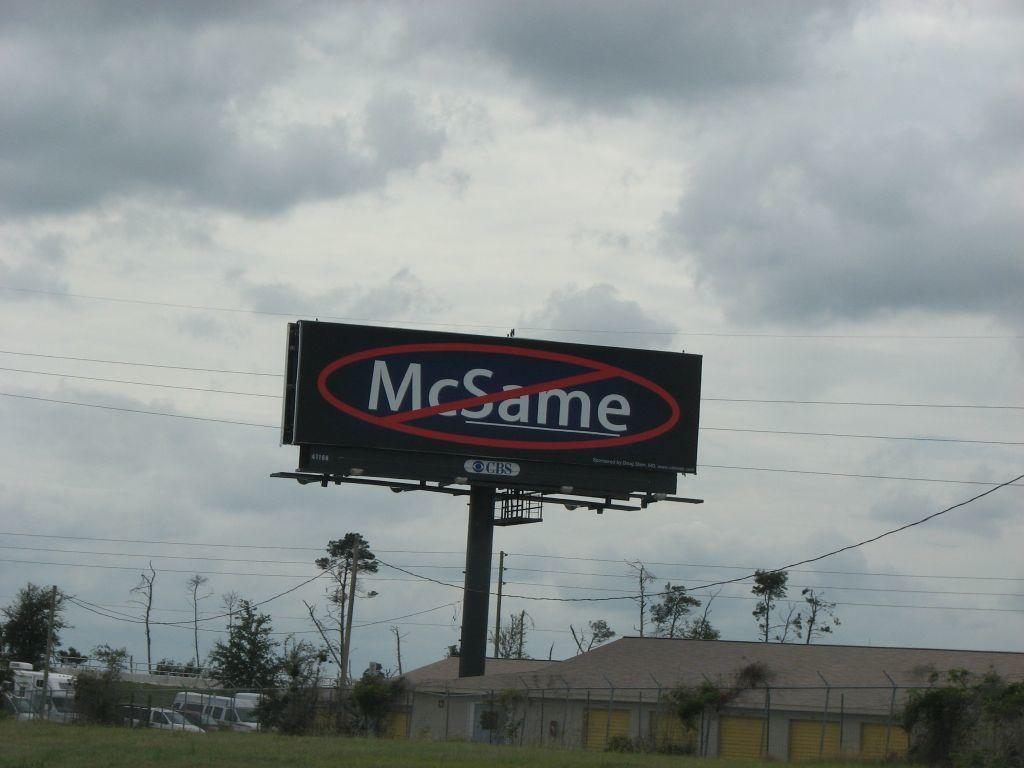<image>
Render a clear and concise summary of the photo. A billboard by CBS that crosses out McSame. 